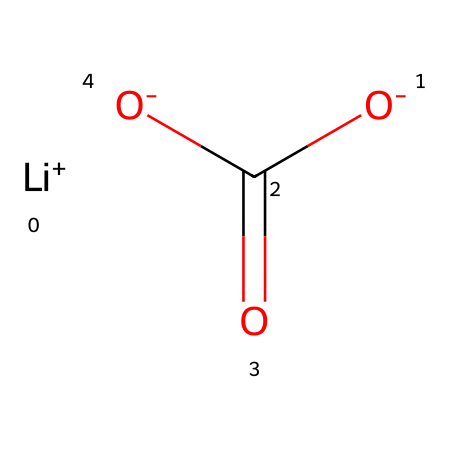What ions are present in this chemical? The SMILES representation shows [Li+] for lithium ion and [O-] indicates the carboxylate ion, which consists of two negatively charged oxygen atoms.
Answer: lithium and carboxylate How many carbon atoms are in this chemical? Analyzing the structure, there is one carbon atom (C) shown in the SMILES representation as part of the carboxylate group O=C(O-).
Answer: one What type of bond connects the lithium ion to the oxygen atom? The lithium ion and the oxygen atom are connected through an ionic bond, as indicated by the charge difference (+ for Li and - for O).
Answer: ionic What functional group is present in this compound? The compound has a carboxylate functional group, indicated by the -C(=O)[O-] part of the SMILES, which consists of a carbonyl (C=O) bonded to a hydroxyl (O–).
Answer: carboxylate What is the overall charge of the compound? The SMILES shows a lithium ion with a +1 charge and a carboxylate group which overall has a -1 charge, resulting in a neutral compound.
Answer: neutral 